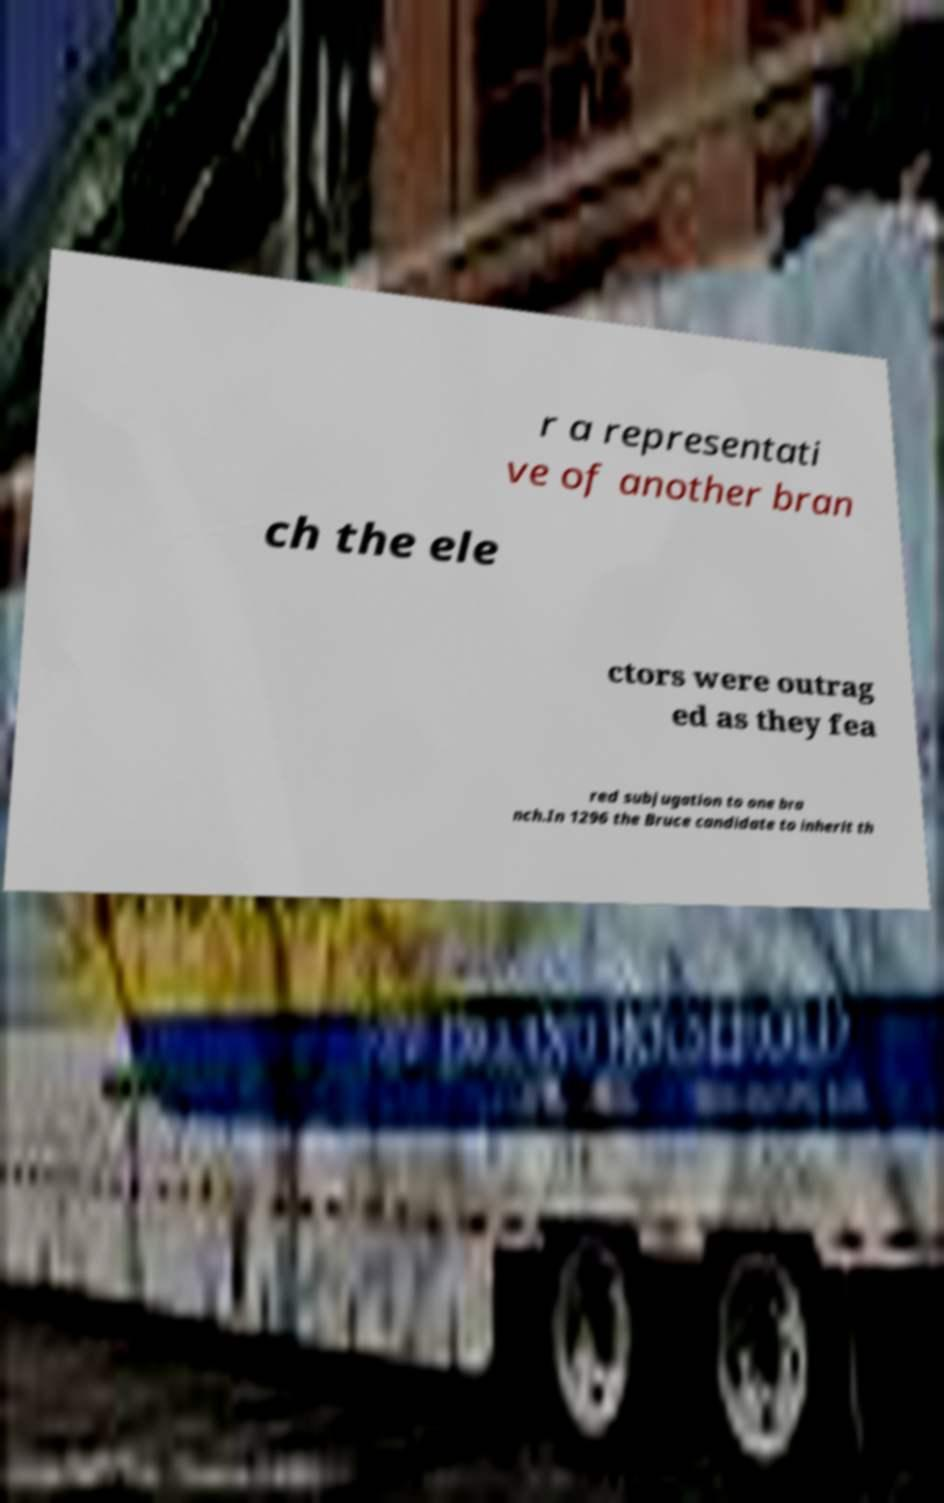Please identify and transcribe the text found in this image. r a representati ve of another bran ch the ele ctors were outrag ed as they fea red subjugation to one bra nch.In 1296 the Bruce candidate to inherit th 